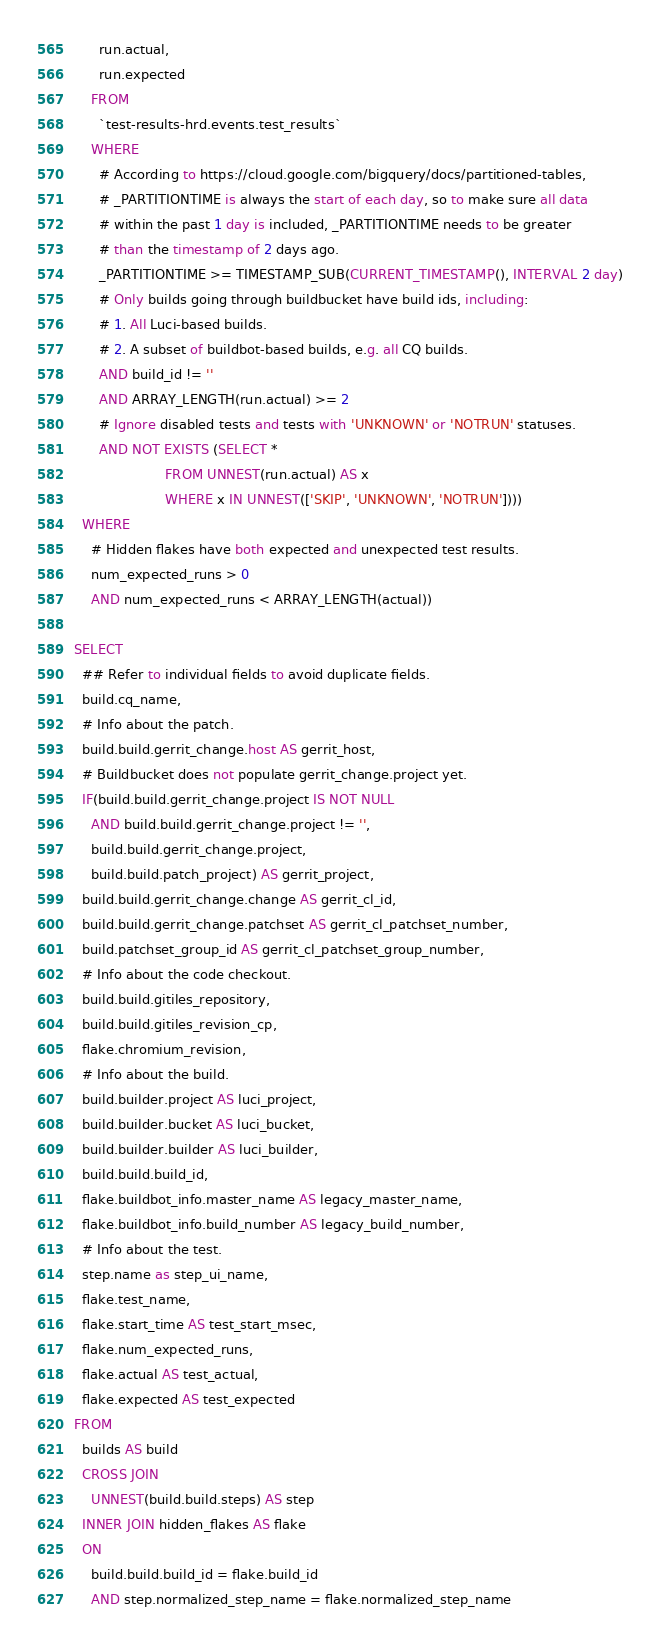<code> <loc_0><loc_0><loc_500><loc_500><_SQL_>      run.actual,
      run.expected
    FROM
      `test-results-hrd.events.test_results`
    WHERE
      # According to https://cloud.google.com/bigquery/docs/partitioned-tables,
      # _PARTITIONTIME is always the start of each day, so to make sure all data
      # within the past 1 day is included, _PARTITIONTIME needs to be greater
      # than the timestamp of 2 days ago.
      _PARTITIONTIME >= TIMESTAMP_SUB(CURRENT_TIMESTAMP(), INTERVAL 2 day)
      # Only builds going through buildbucket have build ids, including:
      # 1. All Luci-based builds.
      # 2. A subset of buildbot-based builds, e.g. all CQ builds.
      AND build_id != ''
      AND ARRAY_LENGTH(run.actual) >= 2
      # Ignore disabled tests and tests with 'UNKNOWN' or 'NOTRUN' statuses.
      AND NOT EXISTS (SELECT *
                      FROM UNNEST(run.actual) AS x
                      WHERE x IN UNNEST(['SKIP', 'UNKNOWN', 'NOTRUN'])))
  WHERE
    # Hidden flakes have both expected and unexpected test results.
    num_expected_runs > 0
    AND num_expected_runs < ARRAY_LENGTH(actual))

SELECT
  ## Refer to individual fields to avoid duplicate fields.
  build.cq_name,
  # Info about the patch.
  build.build.gerrit_change.host AS gerrit_host,
  # Buildbucket does not populate gerrit_change.project yet.
  IF(build.build.gerrit_change.project IS NOT NULL
    AND build.build.gerrit_change.project != '',
    build.build.gerrit_change.project,
    build.build.patch_project) AS gerrit_project,
  build.build.gerrit_change.change AS gerrit_cl_id,
  build.build.gerrit_change.patchset AS gerrit_cl_patchset_number,
  build.patchset_group_id AS gerrit_cl_patchset_group_number,
  # Info about the code checkout.
  build.build.gitiles_repository,
  build.build.gitiles_revision_cp,
  flake.chromium_revision,
  # Info about the build.
  build.builder.project AS luci_project,
  build.builder.bucket AS luci_bucket,
  build.builder.builder AS luci_builder,
  build.build.build_id,
  flake.buildbot_info.master_name AS legacy_master_name,
  flake.buildbot_info.build_number AS legacy_build_number,
  # Info about the test.
  step.name as step_ui_name,
  flake.test_name,
  flake.start_time AS test_start_msec,
  flake.num_expected_runs,
  flake.actual AS test_actual,
  flake.expected AS test_expected
FROM
  builds AS build
  CROSS JOIN
    UNNEST(build.build.steps) AS step
  INNER JOIN hidden_flakes AS flake
  ON
    build.build.build_id = flake.build_id
    AND step.normalized_step_name = flake.normalized_step_name
</code> 